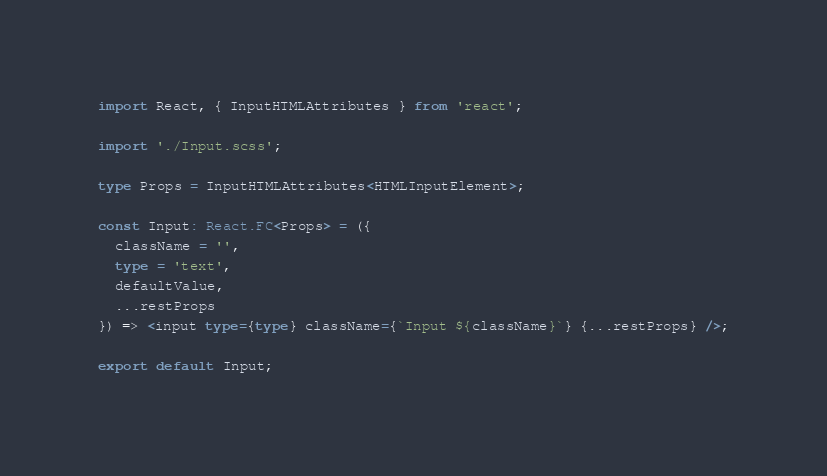<code> <loc_0><loc_0><loc_500><loc_500><_TypeScript_>import React, { InputHTMLAttributes } from 'react';

import './Input.scss';

type Props = InputHTMLAttributes<HTMLInputElement>;

const Input: React.FC<Props> = ({
  className = '',
  type = 'text',
  defaultValue,
  ...restProps
}) => <input type={type} className={`Input ${className}`} {...restProps} />;

export default Input;
</code> 